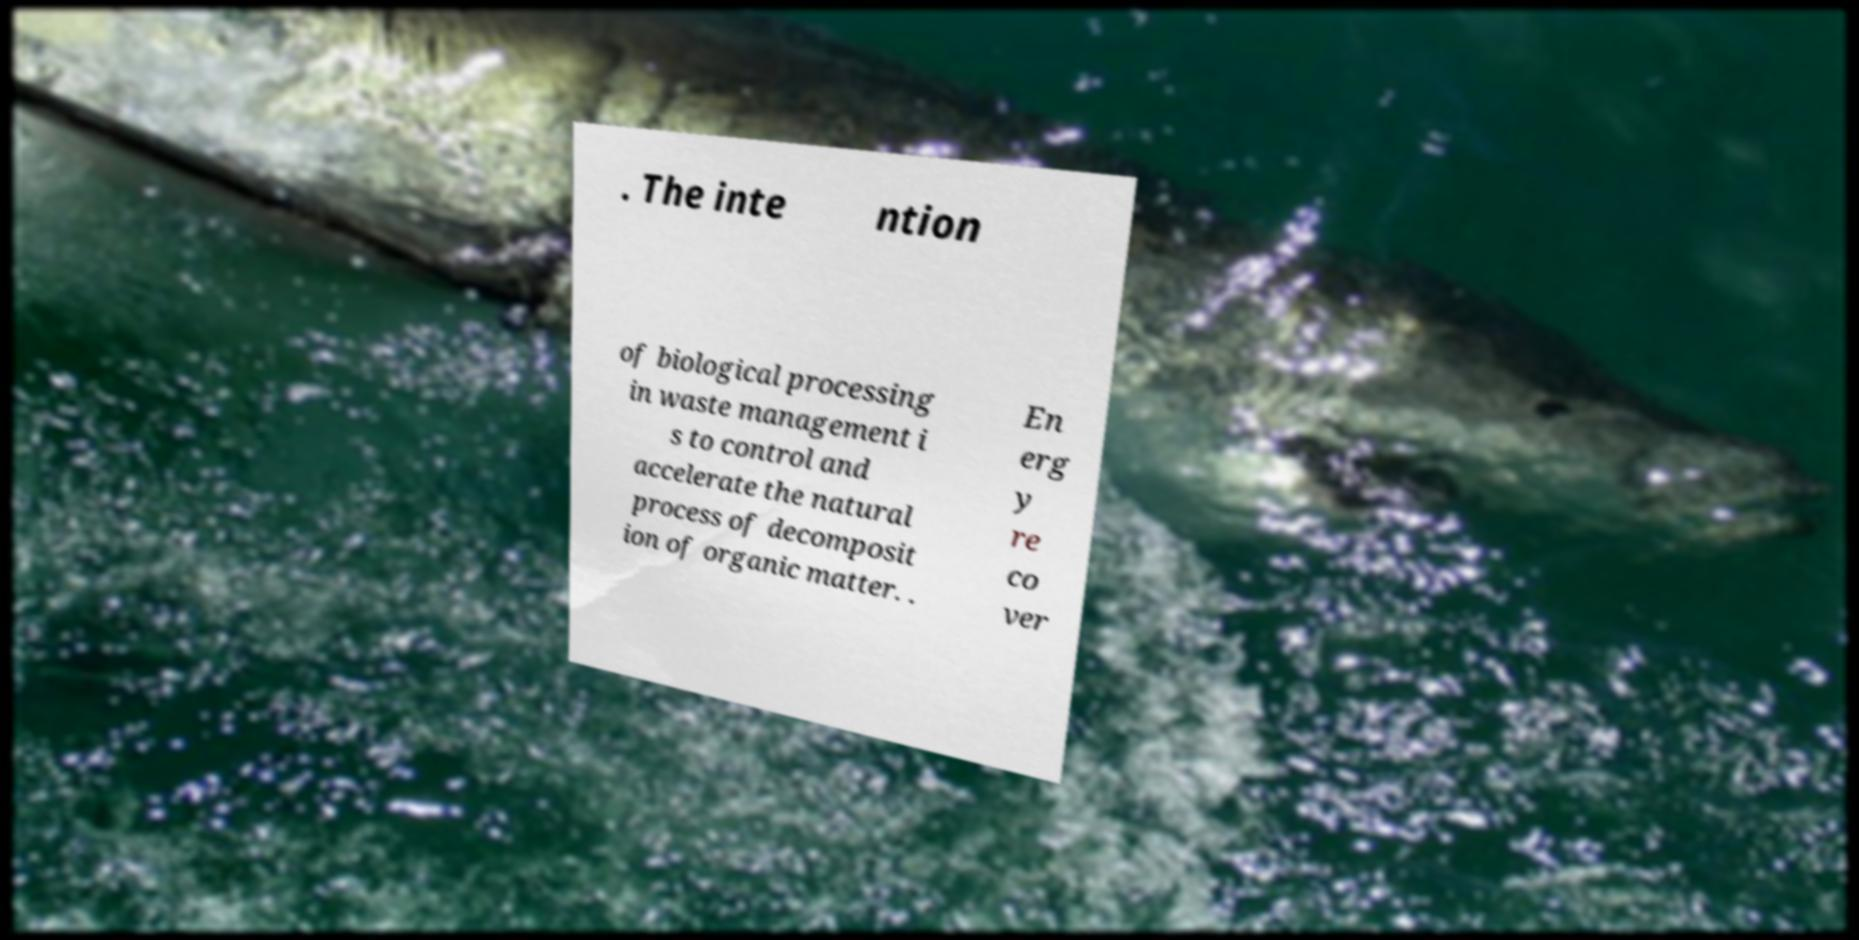Please read and relay the text visible in this image. What does it say? . The inte ntion of biological processing in waste management i s to control and accelerate the natural process of decomposit ion of organic matter. . En erg y re co ver 